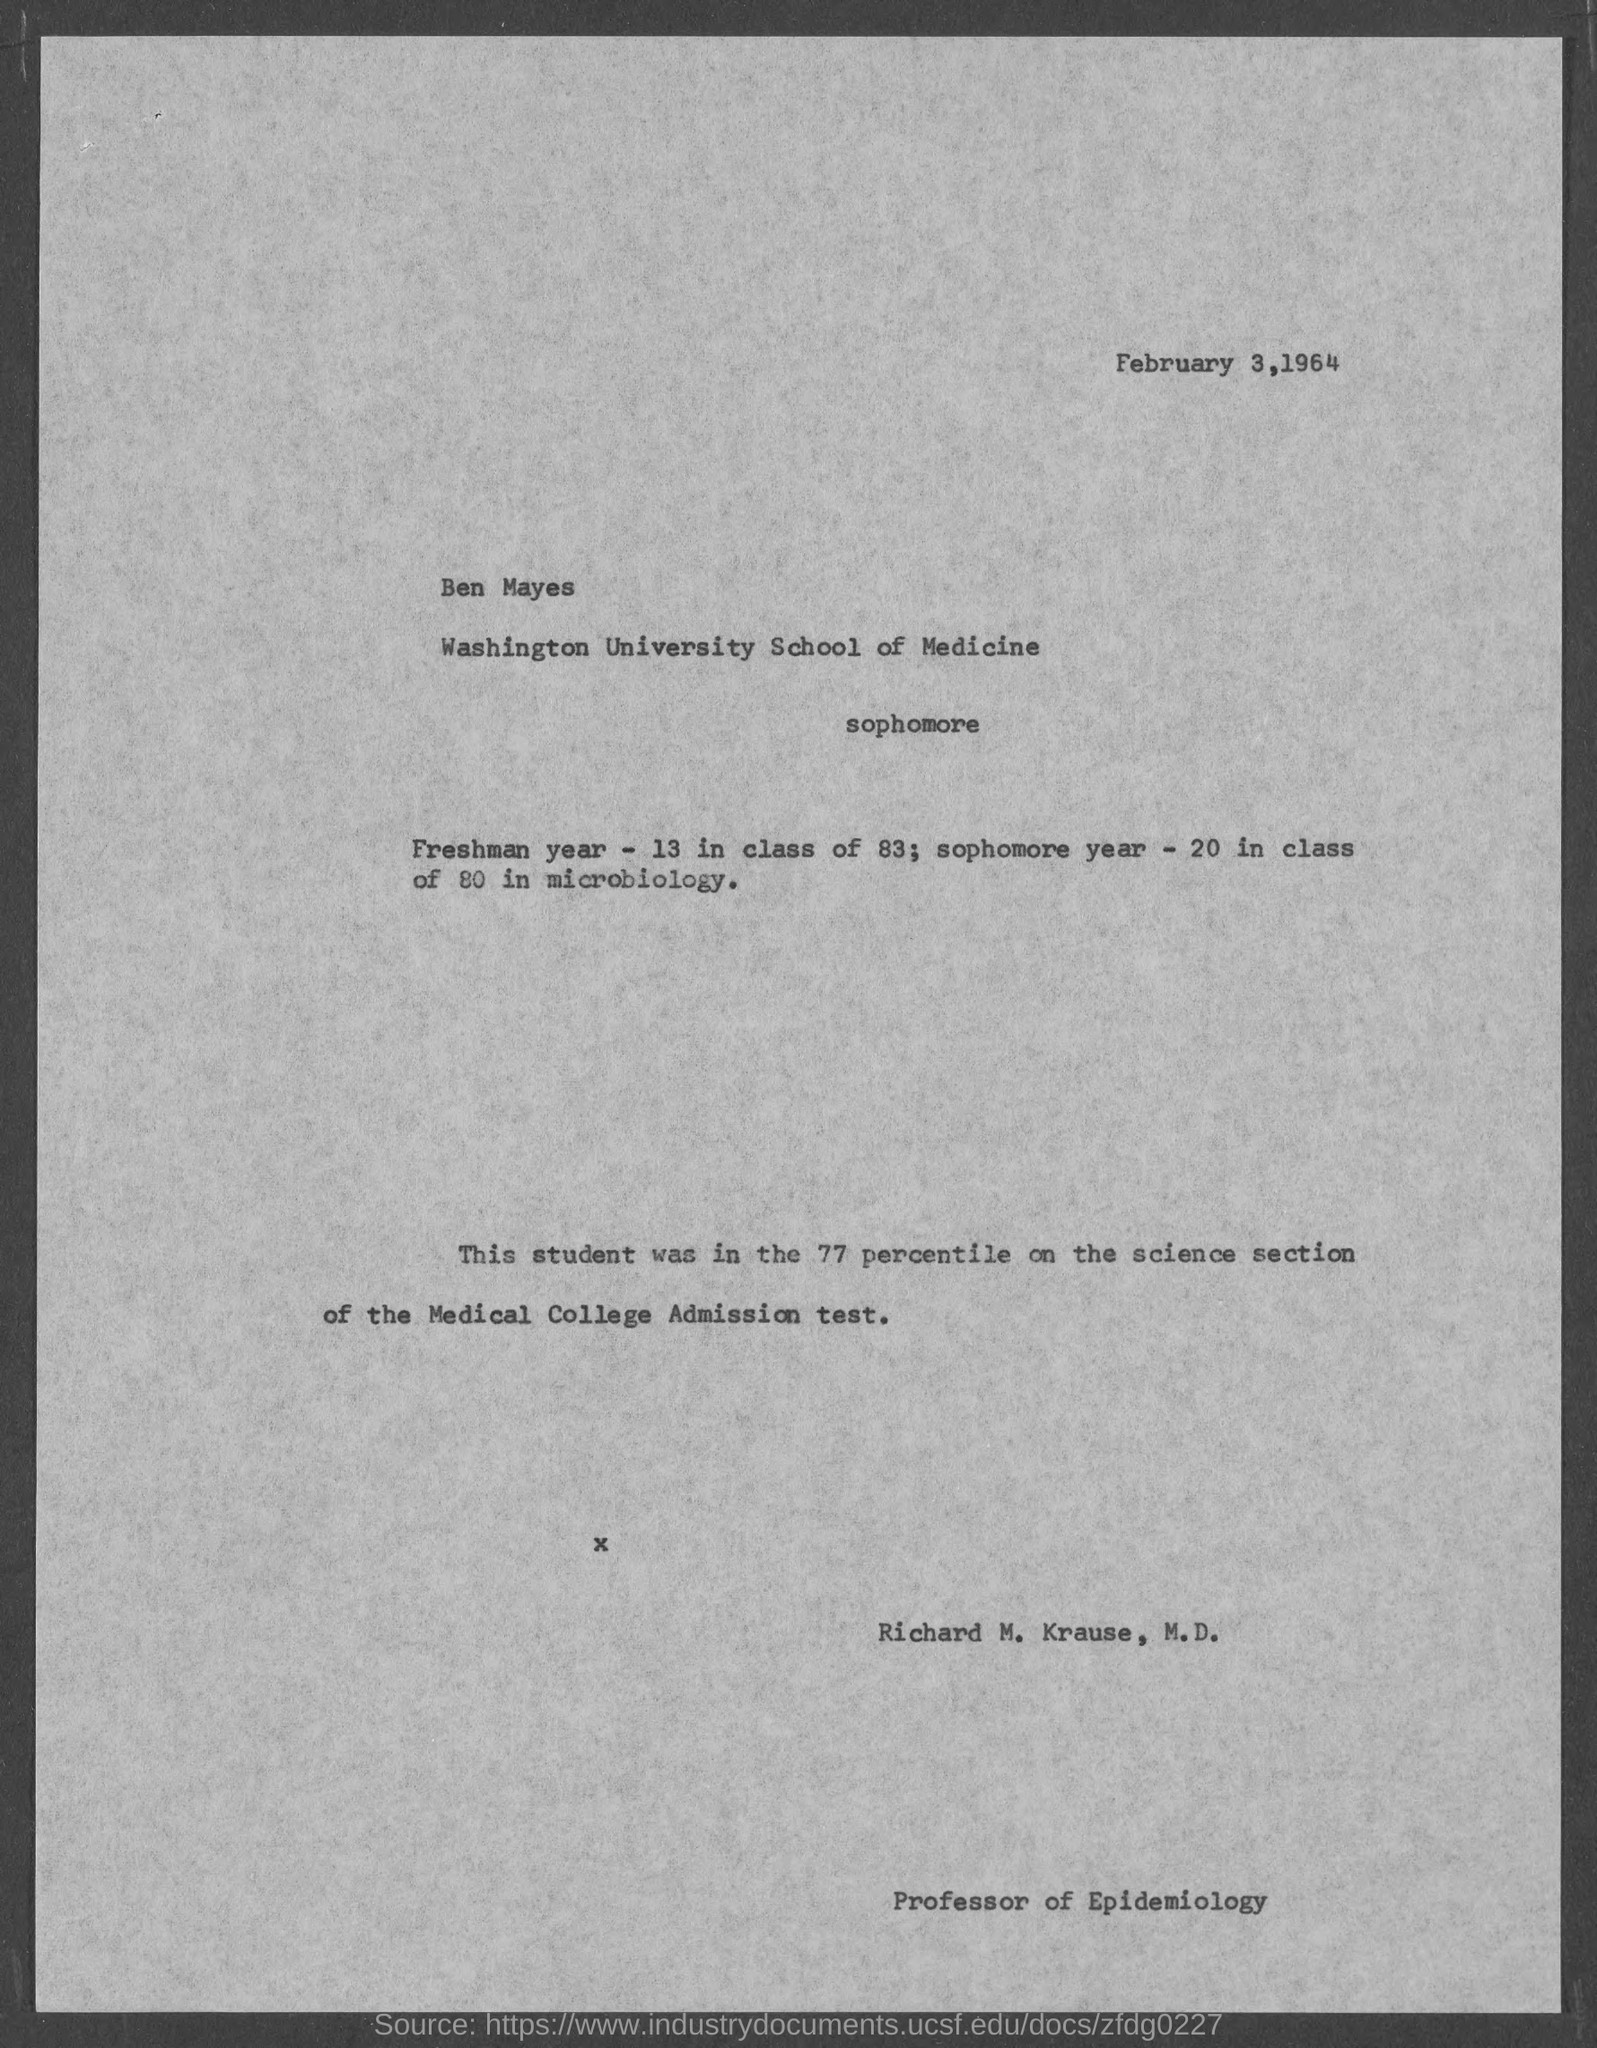Mention a couple of crucial points in this snapshot. Richard M. Krause, M.D. holds the position of Professor of Epidemiology. The date at the top of the page is February 3, 1964. 